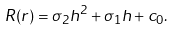Convert formula to latex. <formula><loc_0><loc_0><loc_500><loc_500>R ( r ) = \sigma _ { 2 } h ^ { 2 } + \sigma _ { 1 } h + c _ { 0 } .</formula> 